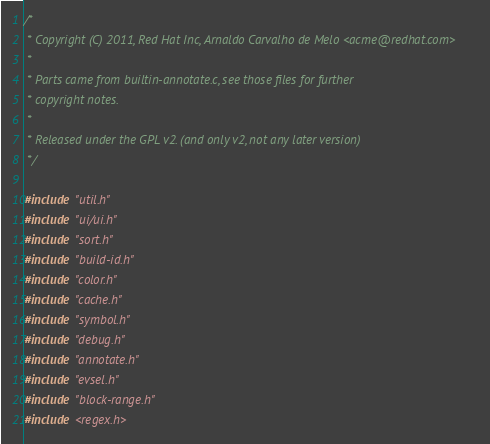Convert code to text. <code><loc_0><loc_0><loc_500><loc_500><_C_>/*
 * Copyright (C) 2011, Red Hat Inc, Arnaldo Carvalho de Melo <acme@redhat.com>
 *
 * Parts came from builtin-annotate.c, see those files for further
 * copyright notes.
 *
 * Released under the GPL v2. (and only v2, not any later version)
 */

#include "util.h"
#include "ui/ui.h"
#include "sort.h"
#include "build-id.h"
#include "color.h"
#include "cache.h"
#include "symbol.h"
#include "debug.h"
#include "annotate.h"
#include "evsel.h"
#include "block-range.h"
#include <regex.h></code> 